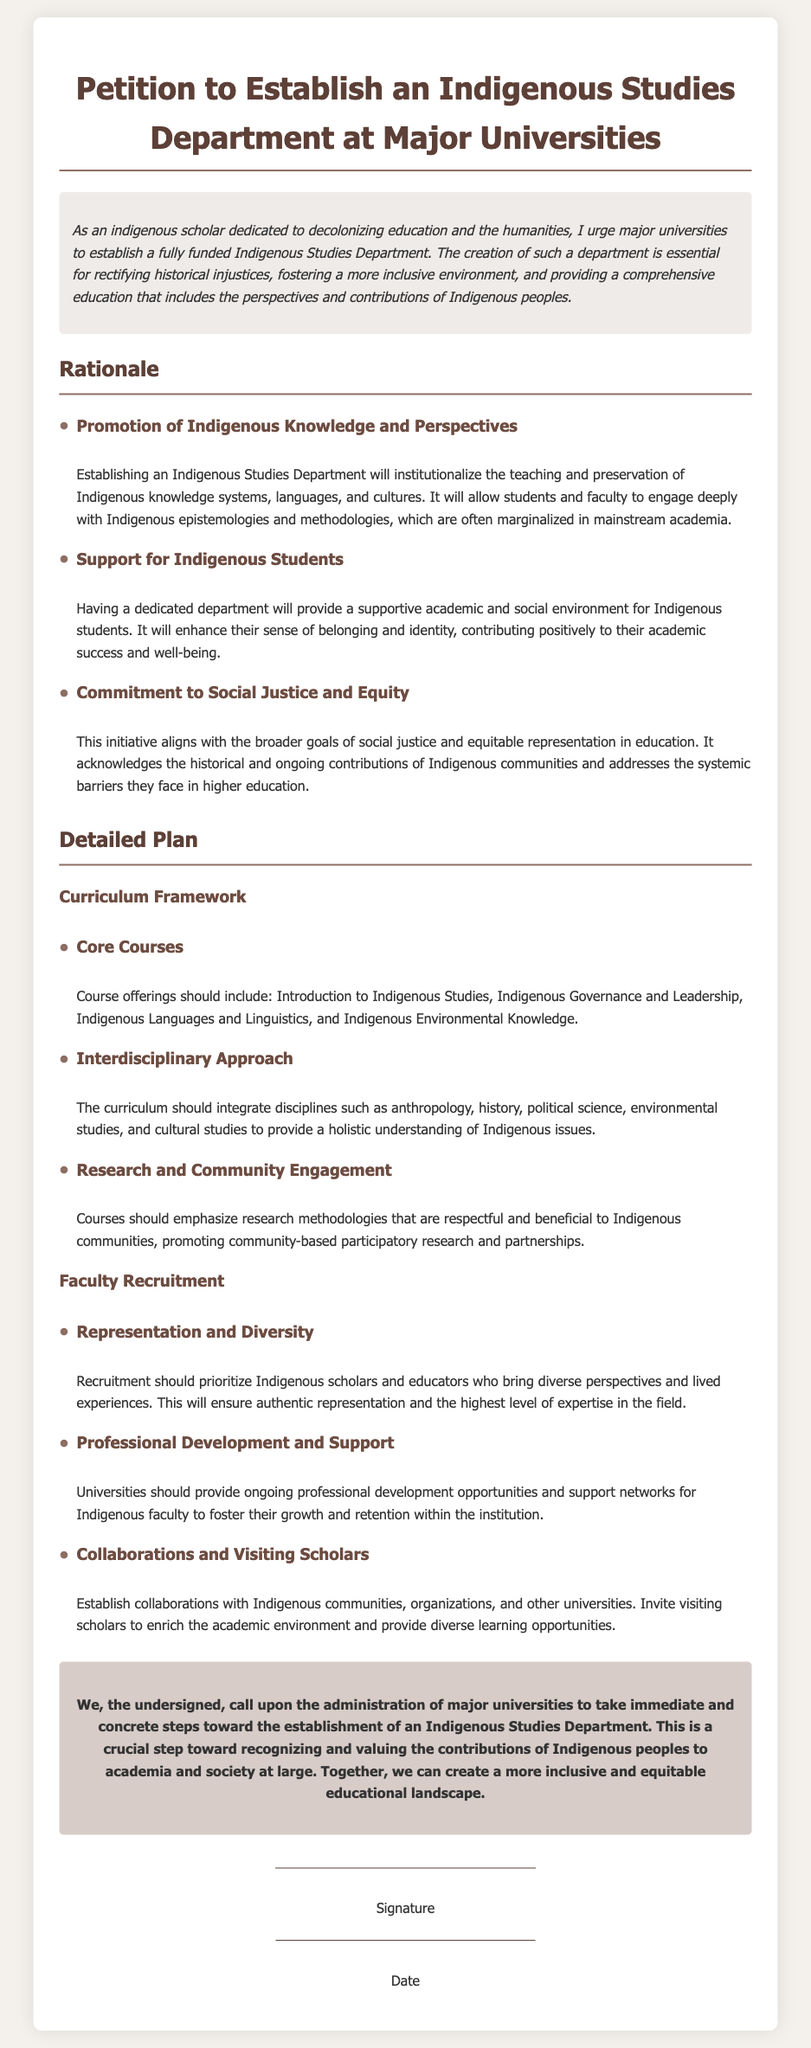what is the title of the petition? The title of the petition is provided at the top of the document.
Answer: Petition to Establish an Indigenous Studies Department at Major Universities who is calling for the establishment of the department? The introduction identifies who is urging the establishment.
Answer: An indigenous scholar what are the core courses suggested? The detailed plan includes a section outlining suggested core courses within the curriculum framework.
Answer: Introduction to Indigenous Studies, Indigenous Governance and Leadership, Indigenous Languages and Linguistics, and Indigenous Environmental Knowledge how many main categories are in the rationale section? The rationale section lists three main categories that support the establishment of the department.
Answer: Three what type of research methodologies should courses emphasize? The document specifies a focus area within the curriculum regarding research methodologies.
Answer: Respectful and beneficial to Indigenous communities which aspect of faculty recruitment is prioritized? The detailed plan discusses a significant aspect related to faculty recruitment.
Answer: Representation and Diversity who should universities collaborate with according to the document? The document suggests a specific group to collaborate with for enrichment and community engagement.
Answer: Indigenous communities what is emphasized for the support of Indigenous faculty? The faculty recruitment section addresses a type of support for Indigenous faculty.
Answer: Ongoing professional development opportunities what is the primary call to action from the signatories? The call-to-action section outlines what the signatories are collectively urging the university administration to do.
Answer: Establish an Indigenous Studies Department 